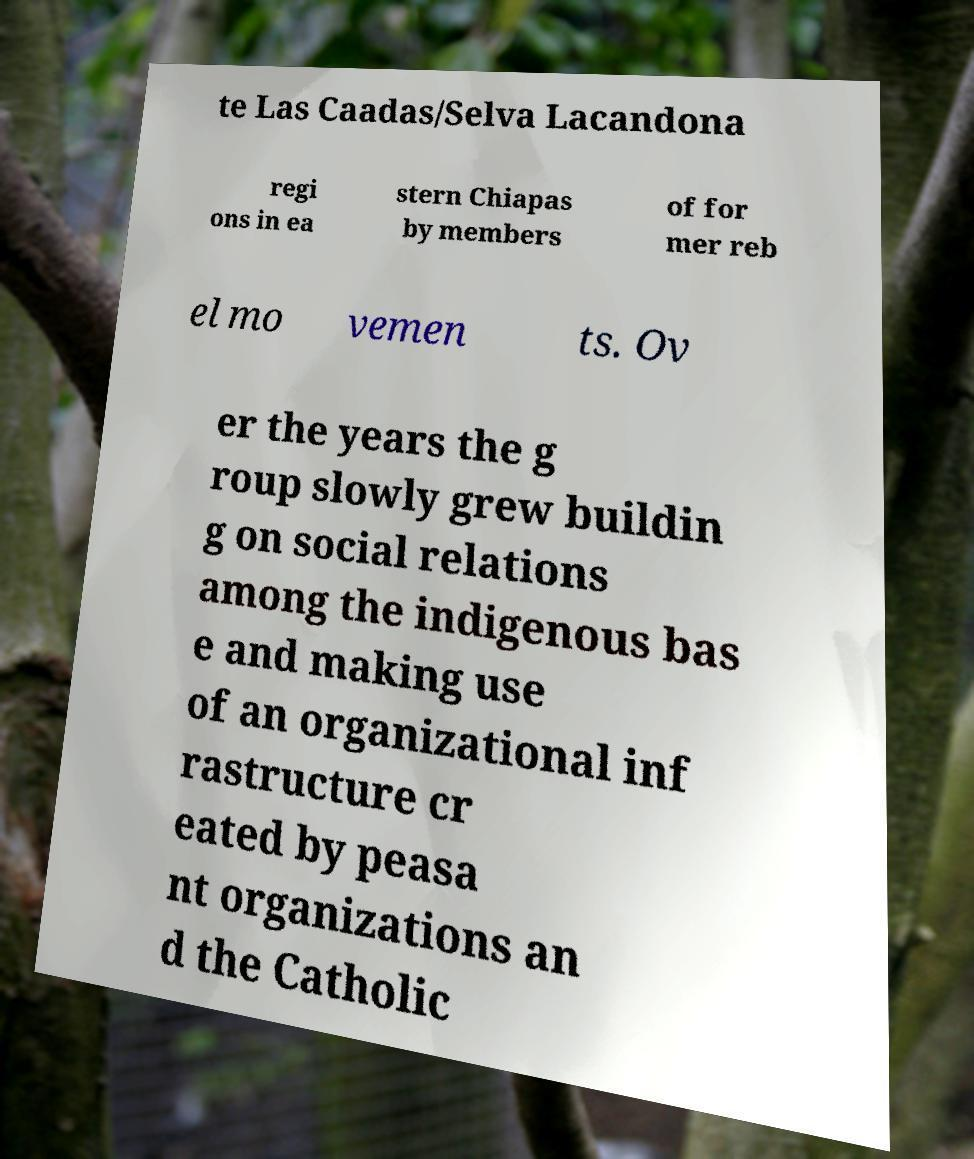Please identify and transcribe the text found in this image. te Las Caadas/Selva Lacandona regi ons in ea stern Chiapas by members of for mer reb el mo vemen ts. Ov er the years the g roup slowly grew buildin g on social relations among the indigenous bas e and making use of an organizational inf rastructure cr eated by peasa nt organizations an d the Catholic 